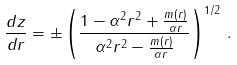Convert formula to latex. <formula><loc_0><loc_0><loc_500><loc_500>\frac { d z } { d r } = \pm \left ( \frac { 1 - \alpha ^ { 2 } r ^ { 2 } + \frac { m ( r ) } { \alpha r } } { \alpha ^ { 2 } r ^ { 2 } - \frac { m ( r ) } { \alpha r } } \right ) ^ { 1 / 2 } \, .</formula> 